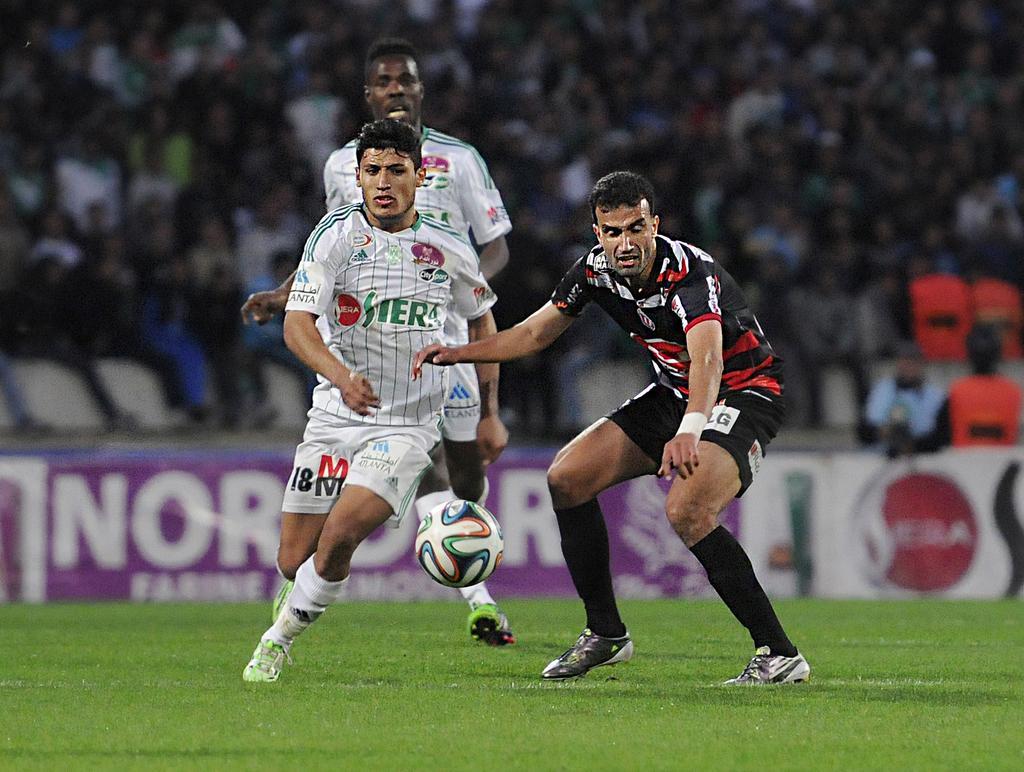Describe this image in one or two sentences. In this image, we can see grass on the ground, we can see three men playing football. In the background, we can see some audience sitting and watching the game. 